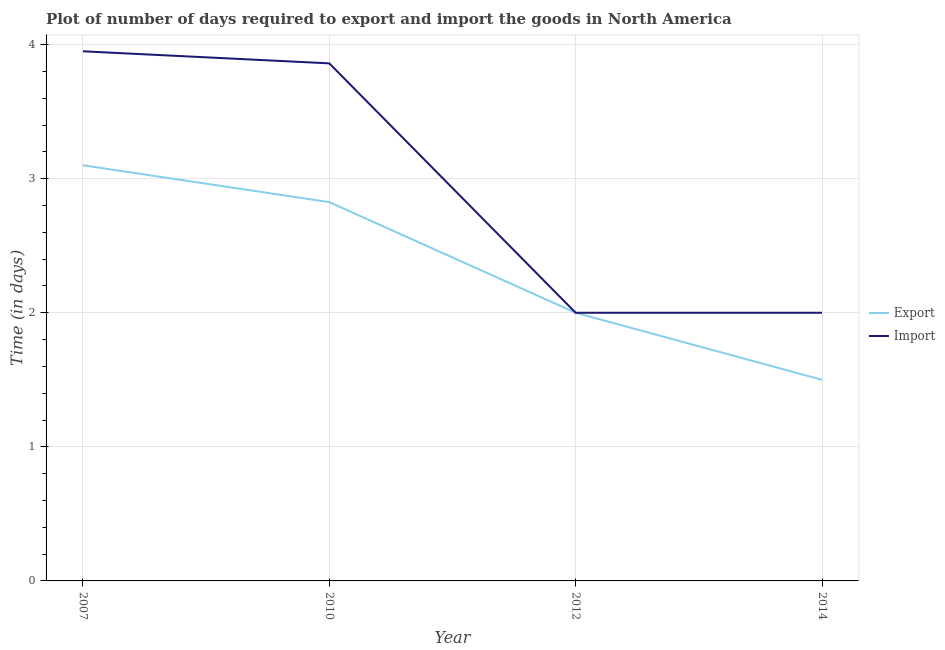How many different coloured lines are there?
Offer a very short reply. 2. Does the line corresponding to time required to export intersect with the line corresponding to time required to import?
Ensure brevity in your answer.  Yes. Is the number of lines equal to the number of legend labels?
Your answer should be very brief. Yes. Across all years, what is the maximum time required to import?
Offer a terse response. 3.95. In which year was the time required to export maximum?
Ensure brevity in your answer.  2007. In which year was the time required to export minimum?
Keep it short and to the point. 2014. What is the total time required to export in the graph?
Provide a succinct answer. 9.43. What is the difference between the time required to import in 2012 and that in 2014?
Give a very brief answer. 0. What is the difference between the time required to export in 2007 and the time required to import in 2010?
Your answer should be compact. -0.76. What is the average time required to import per year?
Your response must be concise. 2.95. In the year 2012, what is the difference between the time required to export and time required to import?
Ensure brevity in your answer.  0. In how many years, is the time required to export greater than 3.4 days?
Your answer should be very brief. 0. What is the ratio of the time required to export in 2007 to that in 2014?
Offer a very short reply. 2.07. Is the difference between the time required to export in 2007 and 2014 greater than the difference between the time required to import in 2007 and 2014?
Provide a succinct answer. No. What is the difference between the highest and the second highest time required to export?
Give a very brief answer. 0.27. What is the difference between the highest and the lowest time required to import?
Ensure brevity in your answer.  1.95. In how many years, is the time required to import greater than the average time required to import taken over all years?
Give a very brief answer. 2. Is the time required to export strictly greater than the time required to import over the years?
Your answer should be compact. No. How many years are there in the graph?
Give a very brief answer. 4. What is the difference between two consecutive major ticks on the Y-axis?
Ensure brevity in your answer.  1. Are the values on the major ticks of Y-axis written in scientific E-notation?
Make the answer very short. No. Does the graph contain any zero values?
Your answer should be very brief. No. Does the graph contain grids?
Ensure brevity in your answer.  Yes. Where does the legend appear in the graph?
Provide a short and direct response. Center right. How many legend labels are there?
Provide a short and direct response. 2. How are the legend labels stacked?
Keep it short and to the point. Vertical. What is the title of the graph?
Offer a very short reply. Plot of number of days required to export and import the goods in North America. What is the label or title of the Y-axis?
Offer a very short reply. Time (in days). What is the Time (in days) of Export in 2007?
Ensure brevity in your answer.  3.1. What is the Time (in days) of Import in 2007?
Offer a very short reply. 3.95. What is the Time (in days) of Export in 2010?
Make the answer very short. 2.83. What is the Time (in days) in Import in 2010?
Ensure brevity in your answer.  3.86. What is the Time (in days) in Import in 2012?
Your answer should be compact. 2. Across all years, what is the maximum Time (in days) of Import?
Offer a very short reply. 3.95. Across all years, what is the minimum Time (in days) in Import?
Your answer should be very brief. 2. What is the total Time (in days) in Export in the graph?
Give a very brief answer. 9.43. What is the total Time (in days) of Import in the graph?
Offer a terse response. 11.81. What is the difference between the Time (in days) in Export in 2007 and that in 2010?
Keep it short and to the point. 0.28. What is the difference between the Time (in days) in Import in 2007 and that in 2010?
Keep it short and to the point. 0.09. What is the difference between the Time (in days) of Export in 2007 and that in 2012?
Your answer should be very brief. 1.1. What is the difference between the Time (in days) in Import in 2007 and that in 2012?
Offer a very short reply. 1.95. What is the difference between the Time (in days) in Import in 2007 and that in 2014?
Offer a very short reply. 1.95. What is the difference between the Time (in days) in Export in 2010 and that in 2012?
Provide a succinct answer. 0.82. What is the difference between the Time (in days) of Import in 2010 and that in 2012?
Offer a terse response. 1.86. What is the difference between the Time (in days) of Export in 2010 and that in 2014?
Make the answer very short. 1.32. What is the difference between the Time (in days) of Import in 2010 and that in 2014?
Your response must be concise. 1.86. What is the difference between the Time (in days) in Export in 2012 and that in 2014?
Ensure brevity in your answer.  0.5. What is the difference between the Time (in days) in Import in 2012 and that in 2014?
Make the answer very short. 0. What is the difference between the Time (in days) of Export in 2007 and the Time (in days) of Import in 2010?
Give a very brief answer. -0.76. What is the difference between the Time (in days) in Export in 2007 and the Time (in days) in Import in 2012?
Your answer should be very brief. 1.1. What is the difference between the Time (in days) of Export in 2007 and the Time (in days) of Import in 2014?
Your answer should be very brief. 1.1. What is the difference between the Time (in days) of Export in 2010 and the Time (in days) of Import in 2012?
Provide a succinct answer. 0.82. What is the difference between the Time (in days) of Export in 2010 and the Time (in days) of Import in 2014?
Your answer should be compact. 0.82. What is the average Time (in days) in Export per year?
Offer a very short reply. 2.36. What is the average Time (in days) of Import per year?
Your answer should be compact. 2.95. In the year 2007, what is the difference between the Time (in days) in Export and Time (in days) in Import?
Ensure brevity in your answer.  -0.85. In the year 2010, what is the difference between the Time (in days) in Export and Time (in days) in Import?
Ensure brevity in your answer.  -1.03. In the year 2012, what is the difference between the Time (in days) of Export and Time (in days) of Import?
Ensure brevity in your answer.  0. In the year 2014, what is the difference between the Time (in days) of Export and Time (in days) of Import?
Provide a succinct answer. -0.5. What is the ratio of the Time (in days) in Export in 2007 to that in 2010?
Your response must be concise. 1.1. What is the ratio of the Time (in days) of Import in 2007 to that in 2010?
Your answer should be very brief. 1.02. What is the ratio of the Time (in days) of Export in 2007 to that in 2012?
Your answer should be very brief. 1.55. What is the ratio of the Time (in days) in Import in 2007 to that in 2012?
Make the answer very short. 1.98. What is the ratio of the Time (in days) of Export in 2007 to that in 2014?
Your answer should be very brief. 2.07. What is the ratio of the Time (in days) of Import in 2007 to that in 2014?
Offer a very short reply. 1.98. What is the ratio of the Time (in days) of Export in 2010 to that in 2012?
Offer a terse response. 1.41. What is the ratio of the Time (in days) in Import in 2010 to that in 2012?
Keep it short and to the point. 1.93. What is the ratio of the Time (in days) in Export in 2010 to that in 2014?
Keep it short and to the point. 1.88. What is the ratio of the Time (in days) of Import in 2010 to that in 2014?
Provide a succinct answer. 1.93. What is the ratio of the Time (in days) of Export in 2012 to that in 2014?
Your answer should be compact. 1.33. What is the ratio of the Time (in days) in Import in 2012 to that in 2014?
Offer a very short reply. 1. What is the difference between the highest and the second highest Time (in days) of Export?
Your answer should be very brief. 0.28. What is the difference between the highest and the second highest Time (in days) in Import?
Your response must be concise. 0.09. What is the difference between the highest and the lowest Time (in days) in Export?
Make the answer very short. 1.6. What is the difference between the highest and the lowest Time (in days) in Import?
Offer a terse response. 1.95. 